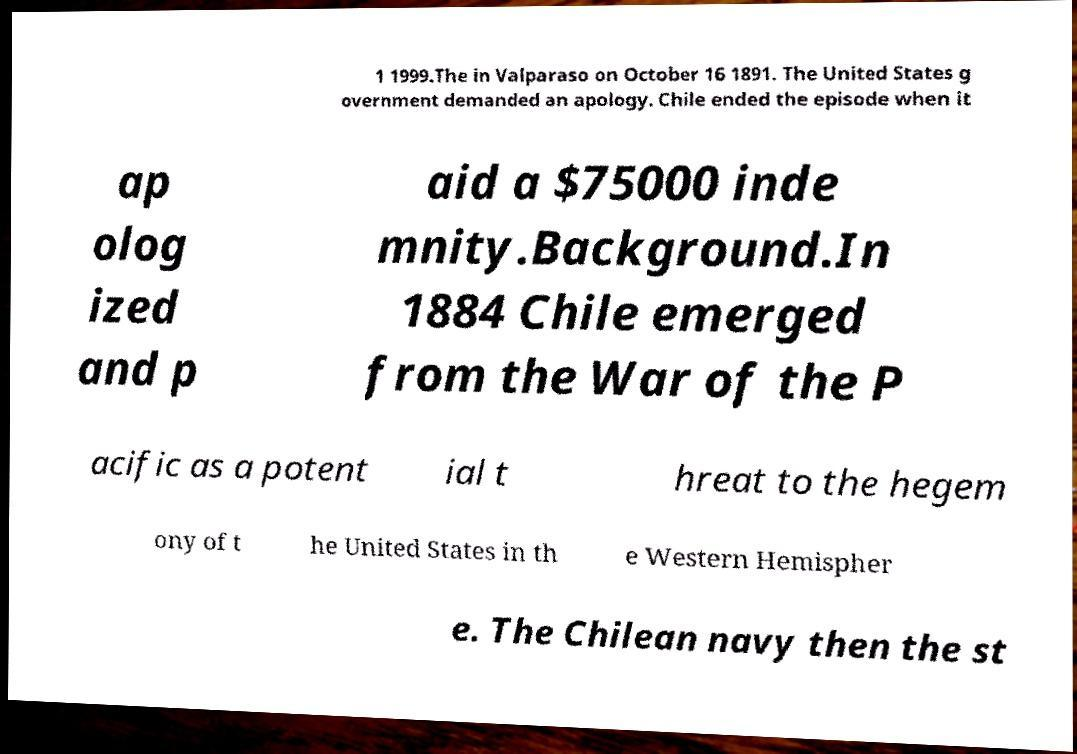Could you assist in decoding the text presented in this image and type it out clearly? 1 1999.The in Valparaso on October 16 1891. The United States g overnment demanded an apology. Chile ended the episode when it ap olog ized and p aid a $75000 inde mnity.Background.In 1884 Chile emerged from the War of the P acific as a potent ial t hreat to the hegem ony of t he United States in th e Western Hemispher e. The Chilean navy then the st 